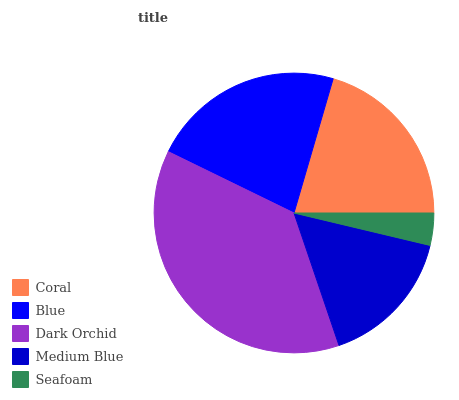Is Seafoam the minimum?
Answer yes or no. Yes. Is Dark Orchid the maximum?
Answer yes or no. Yes. Is Blue the minimum?
Answer yes or no. No. Is Blue the maximum?
Answer yes or no. No. Is Blue greater than Coral?
Answer yes or no. Yes. Is Coral less than Blue?
Answer yes or no. Yes. Is Coral greater than Blue?
Answer yes or no. No. Is Blue less than Coral?
Answer yes or no. No. Is Coral the high median?
Answer yes or no. Yes. Is Coral the low median?
Answer yes or no. Yes. Is Dark Orchid the high median?
Answer yes or no. No. Is Seafoam the low median?
Answer yes or no. No. 